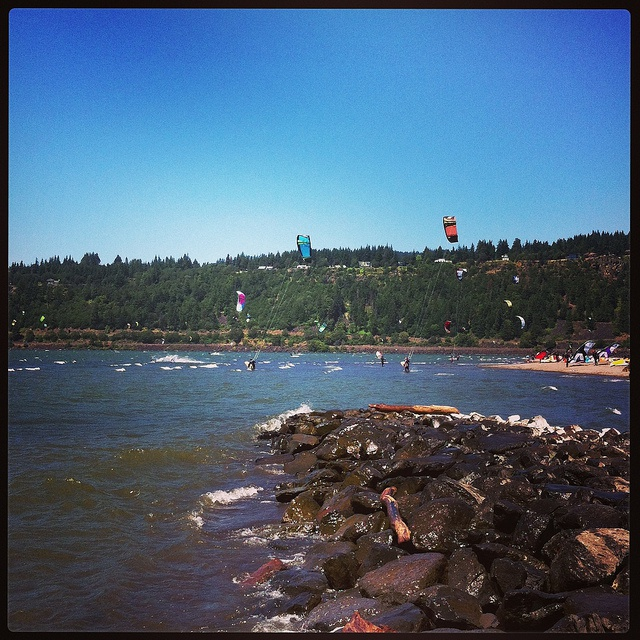Describe the objects in this image and their specific colors. I can see kite in black, lightblue, gray, and teal tones, kite in black, salmon, maroon, and brown tones, kite in black, white, gray, darkgray, and purple tones, people in black, gray, and darkgray tones, and people in black, gray, and purple tones in this image. 